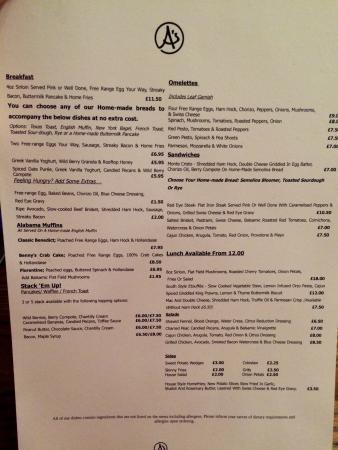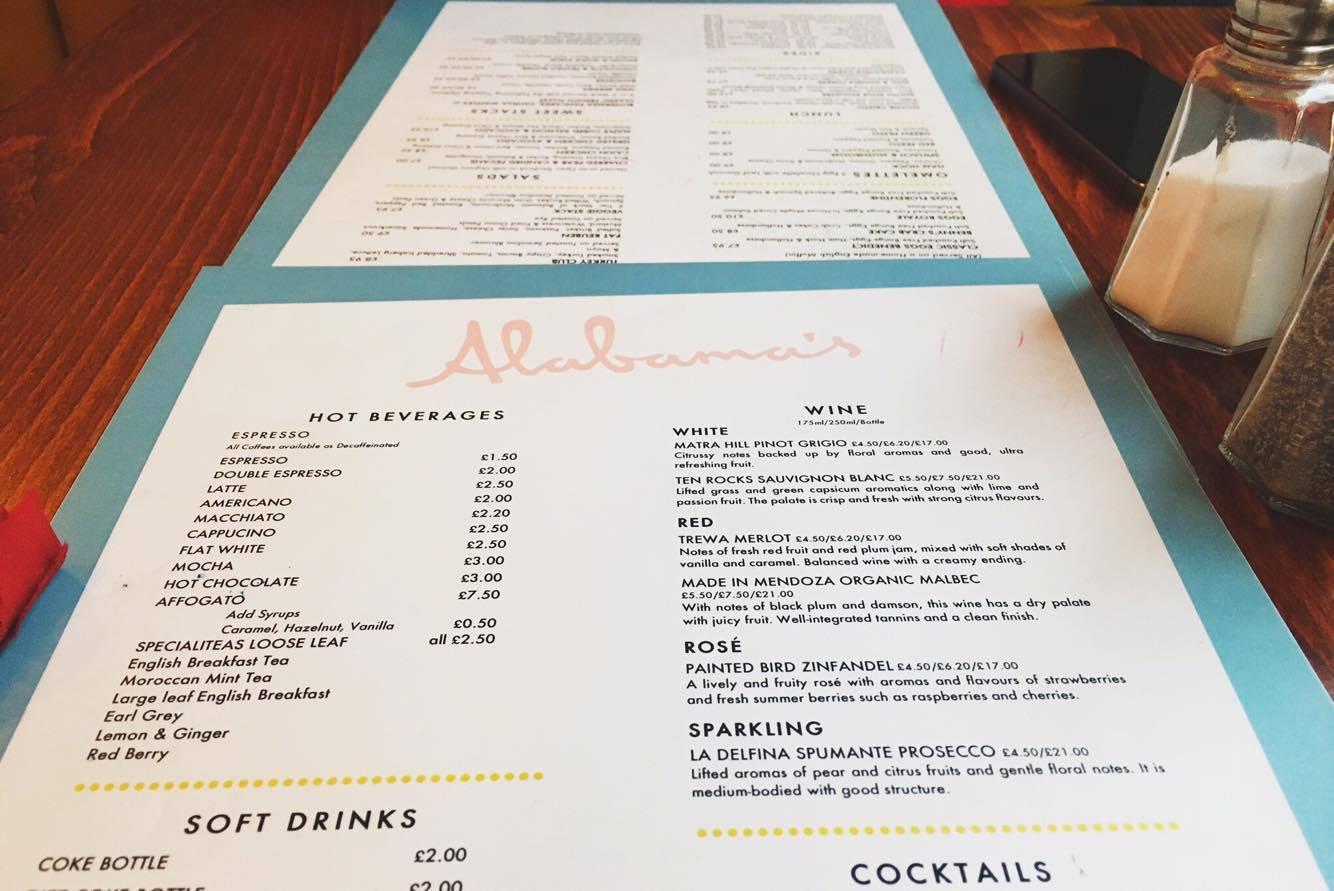The first image is the image on the left, the second image is the image on the right. For the images shown, is this caption "A piece of restaurant related paper sits on a wooden surface in one of the images." true? Answer yes or no. Yes. The first image is the image on the left, the second image is the image on the right. Assess this claim about the two images: "There are exactly two menus.". Correct or not? Answer yes or no. No. 